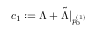Convert formula to latex. <formula><loc_0><loc_0><loc_500><loc_500>c _ { 1 } \colon = \Lambda + \tilde { \Lambda } | _ { p _ { 0 } ^ { ( 1 ) } }</formula> 